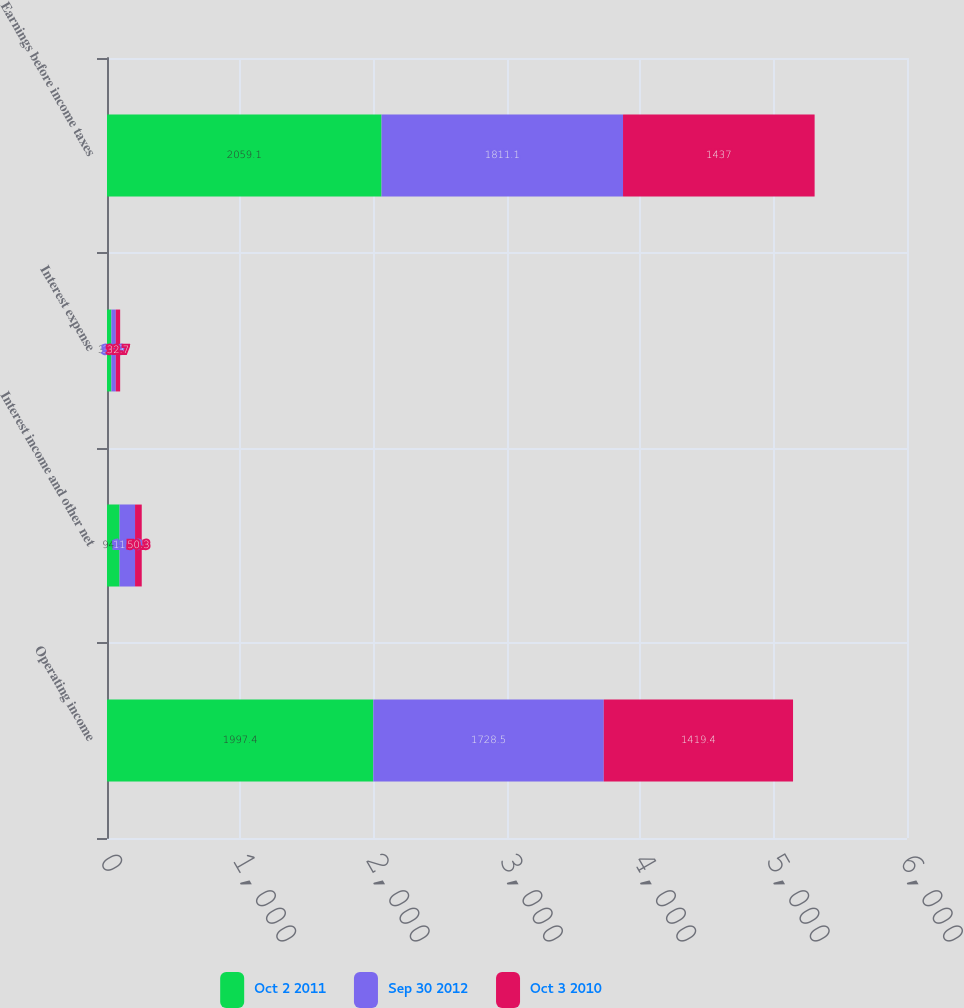Convert chart to OTSL. <chart><loc_0><loc_0><loc_500><loc_500><stacked_bar_chart><ecel><fcel>Operating income<fcel>Interest income and other net<fcel>Interest expense<fcel>Earnings before income taxes<nl><fcel>Oct 2 2011<fcel>1997.4<fcel>94.4<fcel>32.7<fcel>2059.1<nl><fcel>Sep 30 2012<fcel>1728.5<fcel>115.9<fcel>33.3<fcel>1811.1<nl><fcel>Oct 3 2010<fcel>1419.4<fcel>50.3<fcel>32.7<fcel>1437<nl></chart> 